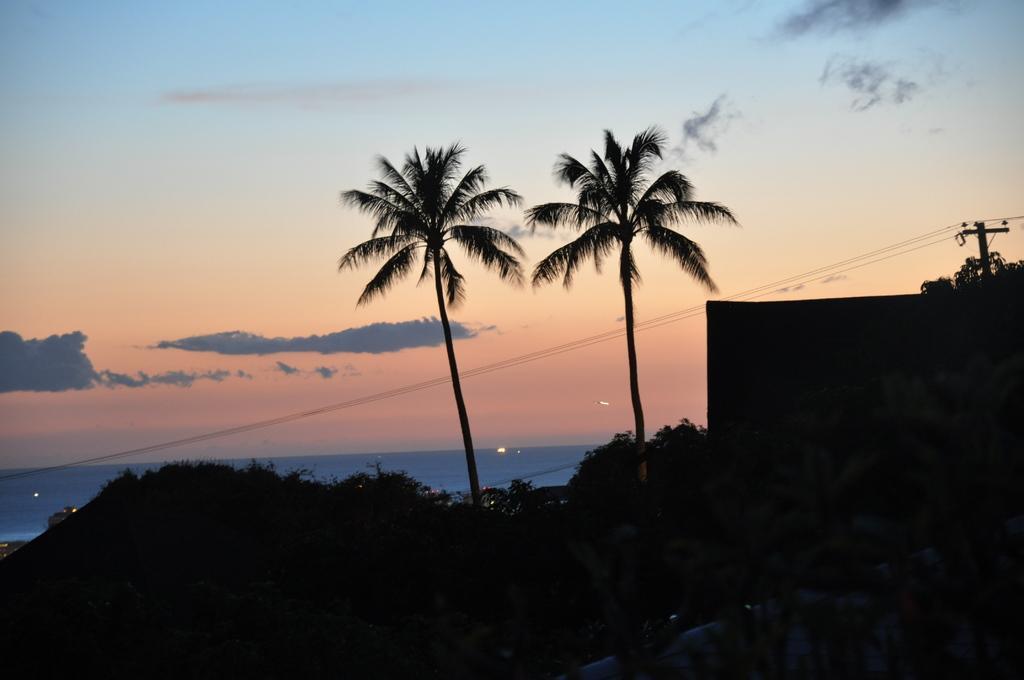Can you describe this image briefly? In this image I can see trees, building and a pole which has wires. In the background I can see the sky. 